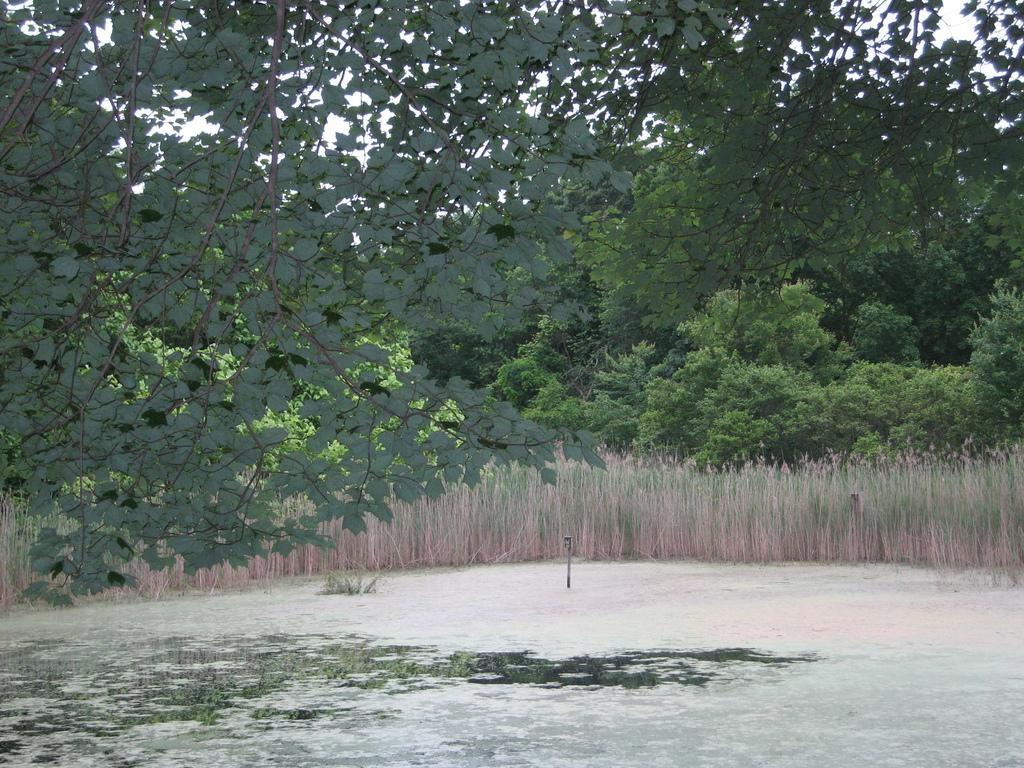Please provide a concise description of this image. In the image there are branches of trees and under the branches there are plants and behind the plants there are plenty of trees. 